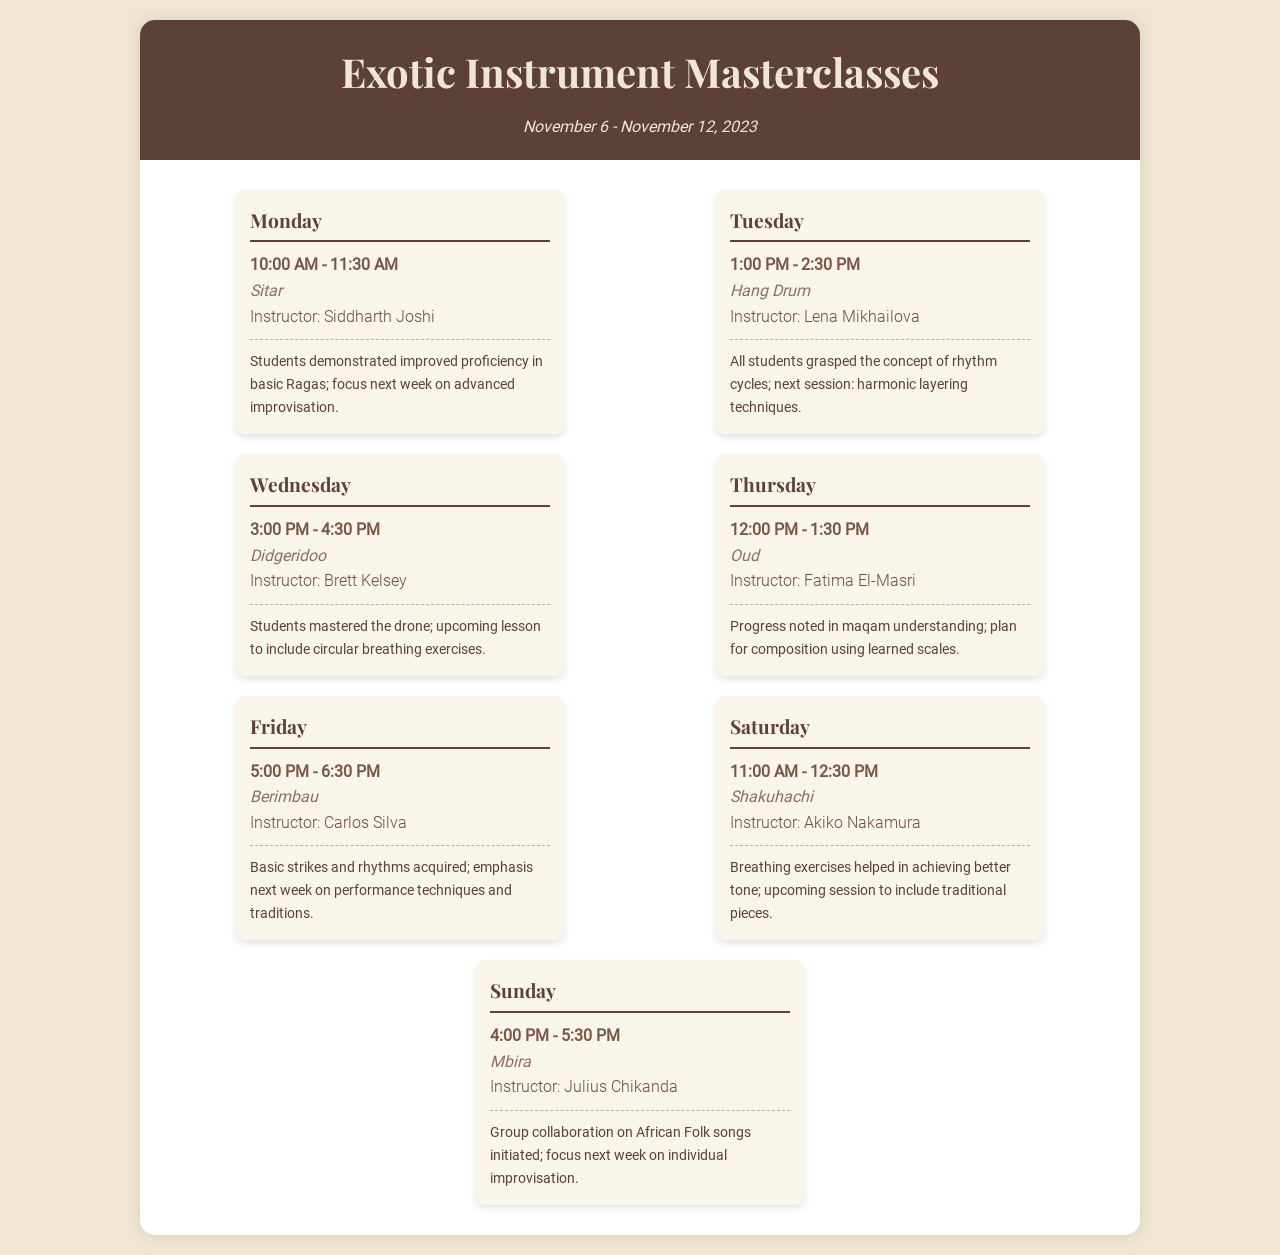What instrument is being focused on during Monday's session? Monday's session focuses on the Sitar as indicated in the schedule.
Answer: Sitar Who is the instructor for the Hang Drum class? The instructor for the Hang Drum class on Tuesday is Lena Mikhailova.
Answer: Lena Mikhailova What time does the Didgeridoo lesson start on Wednesday? The Didgeridoo lesson starts at 3:00 PM on Wednesday according to the schedule.
Answer: 3:00 PM What is the primary focus for the Shakuhachi class on Saturday? The primary focus for the Shakuhachi class is on breathing exercises and traditional pieces, as stated in the progress notes.
Answer: Breathing exercises and traditional pieces How long is each masterclass session on Friday? Each masterclass session on Friday lasts for 1.5 hours from 5:00 PM to 6:30 PM.
Answer: 1.5 hours Which day features the Mbira class? The Mbira class is scheduled for Sunday as mentioned in the document.
Answer: Sunday What was the progress noted in the Oud lessons? Progress noted in the Oud lessons includes understanding maqam, as outlined in the progress notes.
Answer: Maqam understanding What is a key focus for the Didgeridoo lesson next week? A key focus for the Didgeridoo lesson next week will be circular breathing exercises according to the notes.
Answer: Circular breathing exercises On which day is the Berimbau session held? The Berimbau session is held on Friday as indicated in the schedule.
Answer: Friday 